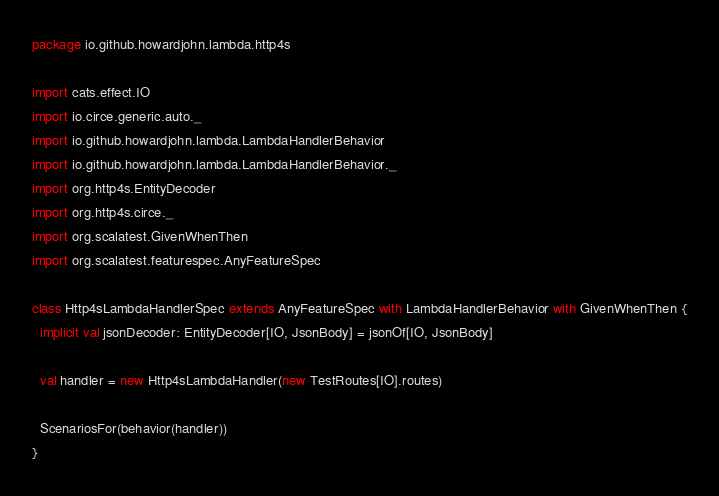Convert code to text. <code><loc_0><loc_0><loc_500><loc_500><_Scala_>package io.github.howardjohn.lambda.http4s

import cats.effect.IO
import io.circe.generic.auto._
import io.github.howardjohn.lambda.LambdaHandlerBehavior
import io.github.howardjohn.lambda.LambdaHandlerBehavior._
import org.http4s.EntityDecoder
import org.http4s.circe._
import org.scalatest.GivenWhenThen
import org.scalatest.featurespec.AnyFeatureSpec

class Http4sLambdaHandlerSpec extends AnyFeatureSpec with LambdaHandlerBehavior with GivenWhenThen {
  implicit val jsonDecoder: EntityDecoder[IO, JsonBody] = jsonOf[IO, JsonBody]

  val handler = new Http4sLambdaHandler(new TestRoutes[IO].routes)

  ScenariosFor(behavior(handler))
}
</code> 